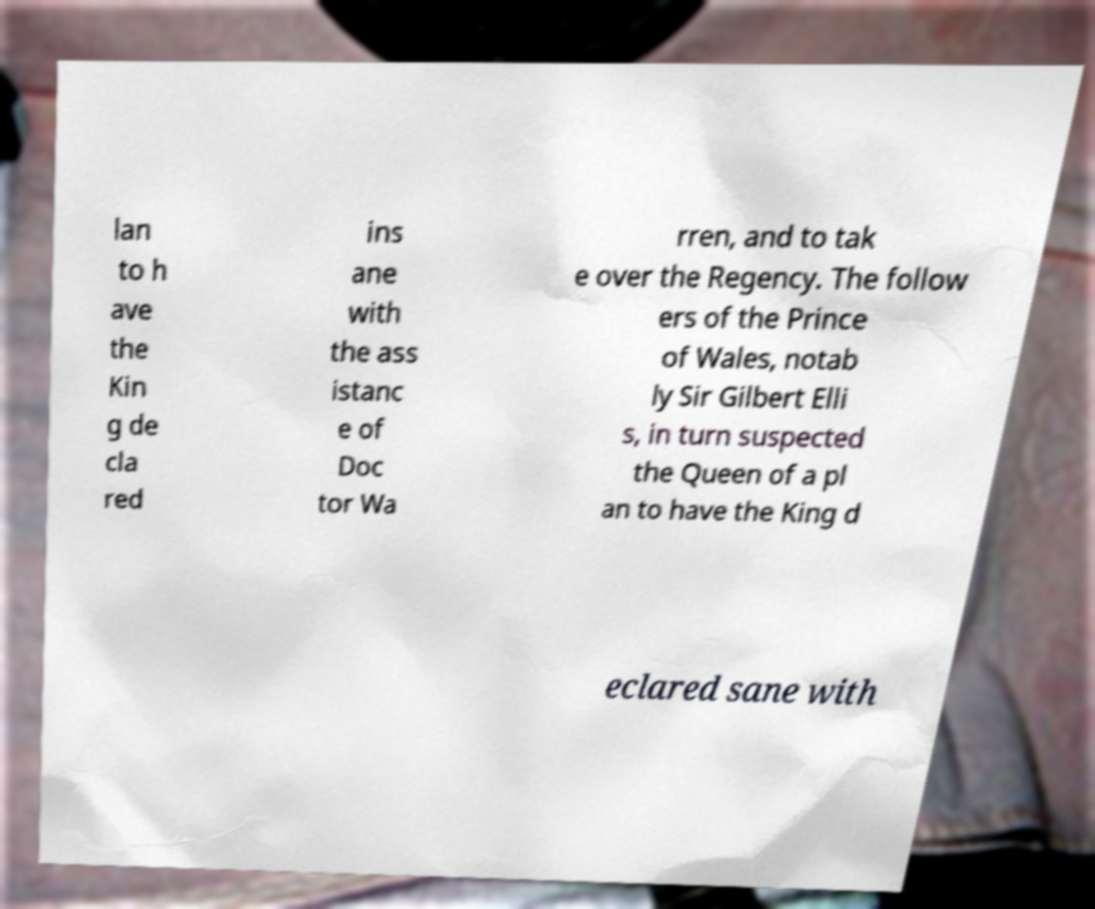Can you read and provide the text displayed in the image?This photo seems to have some interesting text. Can you extract and type it out for me? lan to h ave the Kin g de cla red ins ane with the ass istanc e of Doc tor Wa rren, and to tak e over the Regency. The follow ers of the Prince of Wales, notab ly Sir Gilbert Elli s, in turn suspected the Queen of a pl an to have the King d eclared sane with 